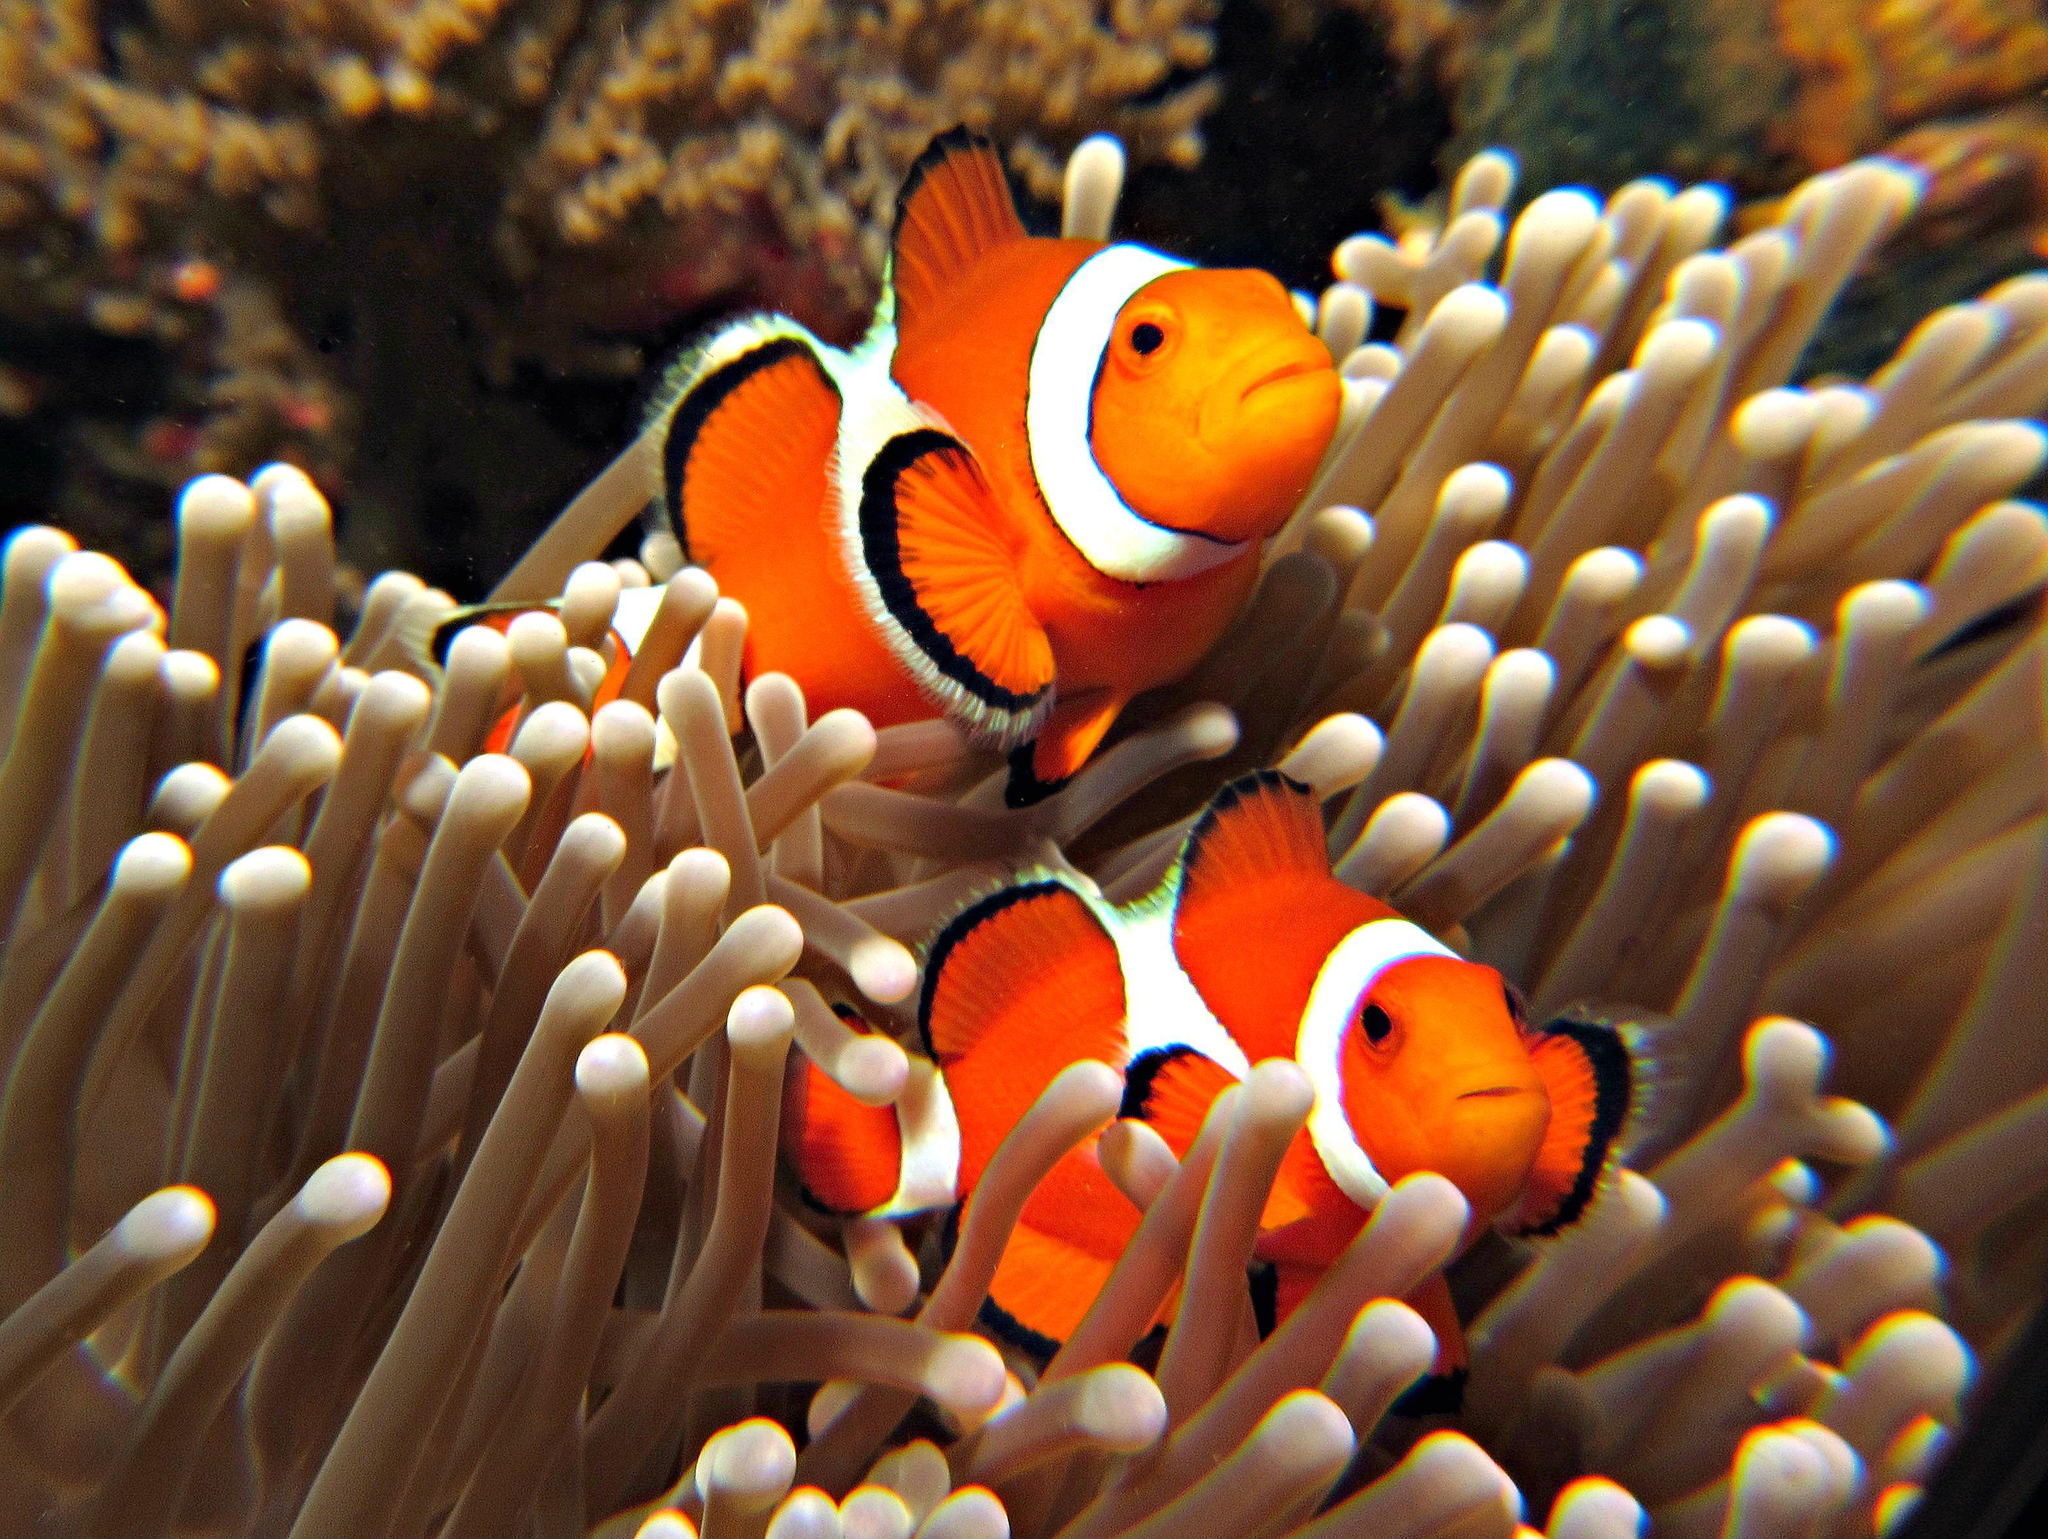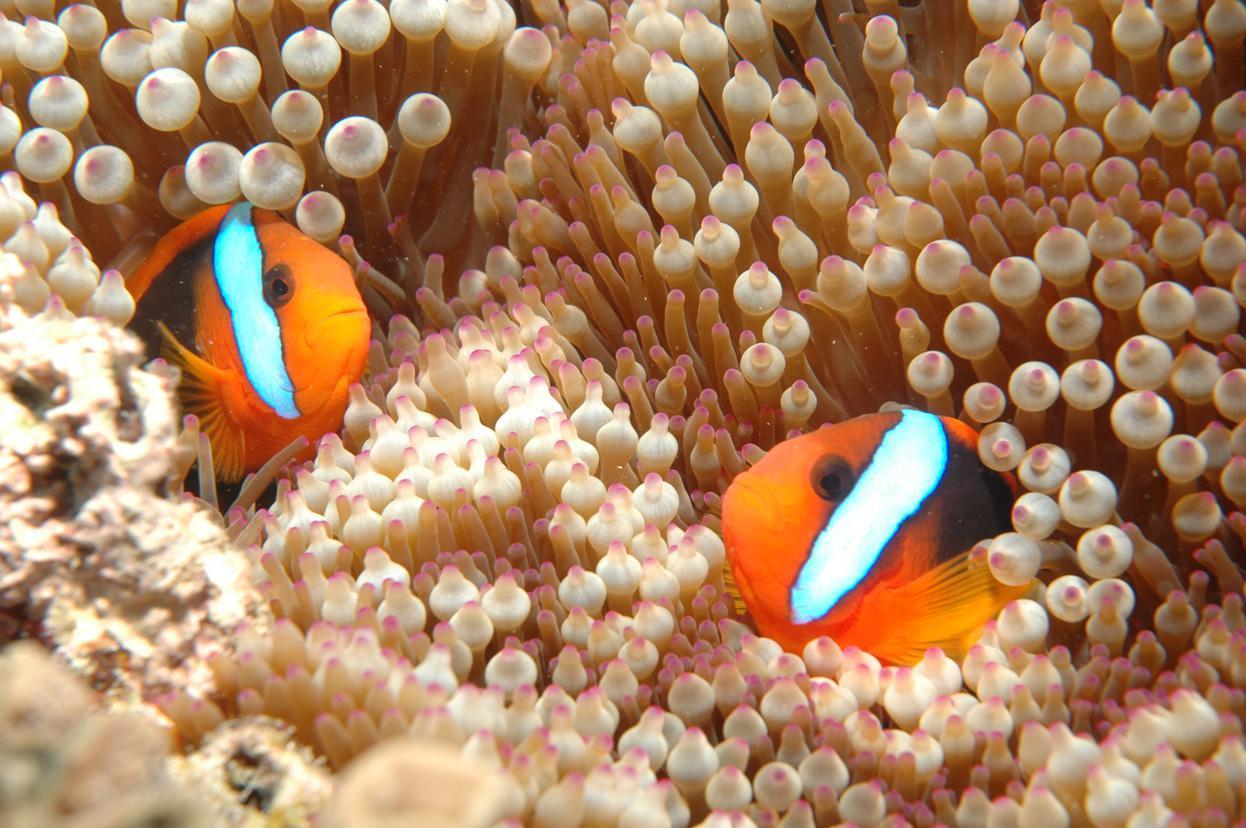The first image is the image on the left, the second image is the image on the right. Examine the images to the left and right. Is the description "Each image contains the same number of clown fish swimming among anemone tendrils." accurate? Answer yes or no. Yes. The first image is the image on the left, the second image is the image on the right. Considering the images on both sides, is "One single fish is swimming in the image on the right." valid? Answer yes or no. No. 